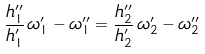Convert formula to latex. <formula><loc_0><loc_0><loc_500><loc_500>\frac { h ^ { \prime \prime } _ { 1 } } { h ^ { \prime } _ { 1 } } \, \omega ^ { \prime } _ { 1 } - \omega ^ { \prime \prime } _ { 1 } = \frac { h ^ { \prime \prime } _ { 2 } } { h ^ { \prime } _ { 2 } } \, \omega ^ { \prime } _ { 2 } - \omega ^ { \prime \prime } _ { 2 }</formula> 